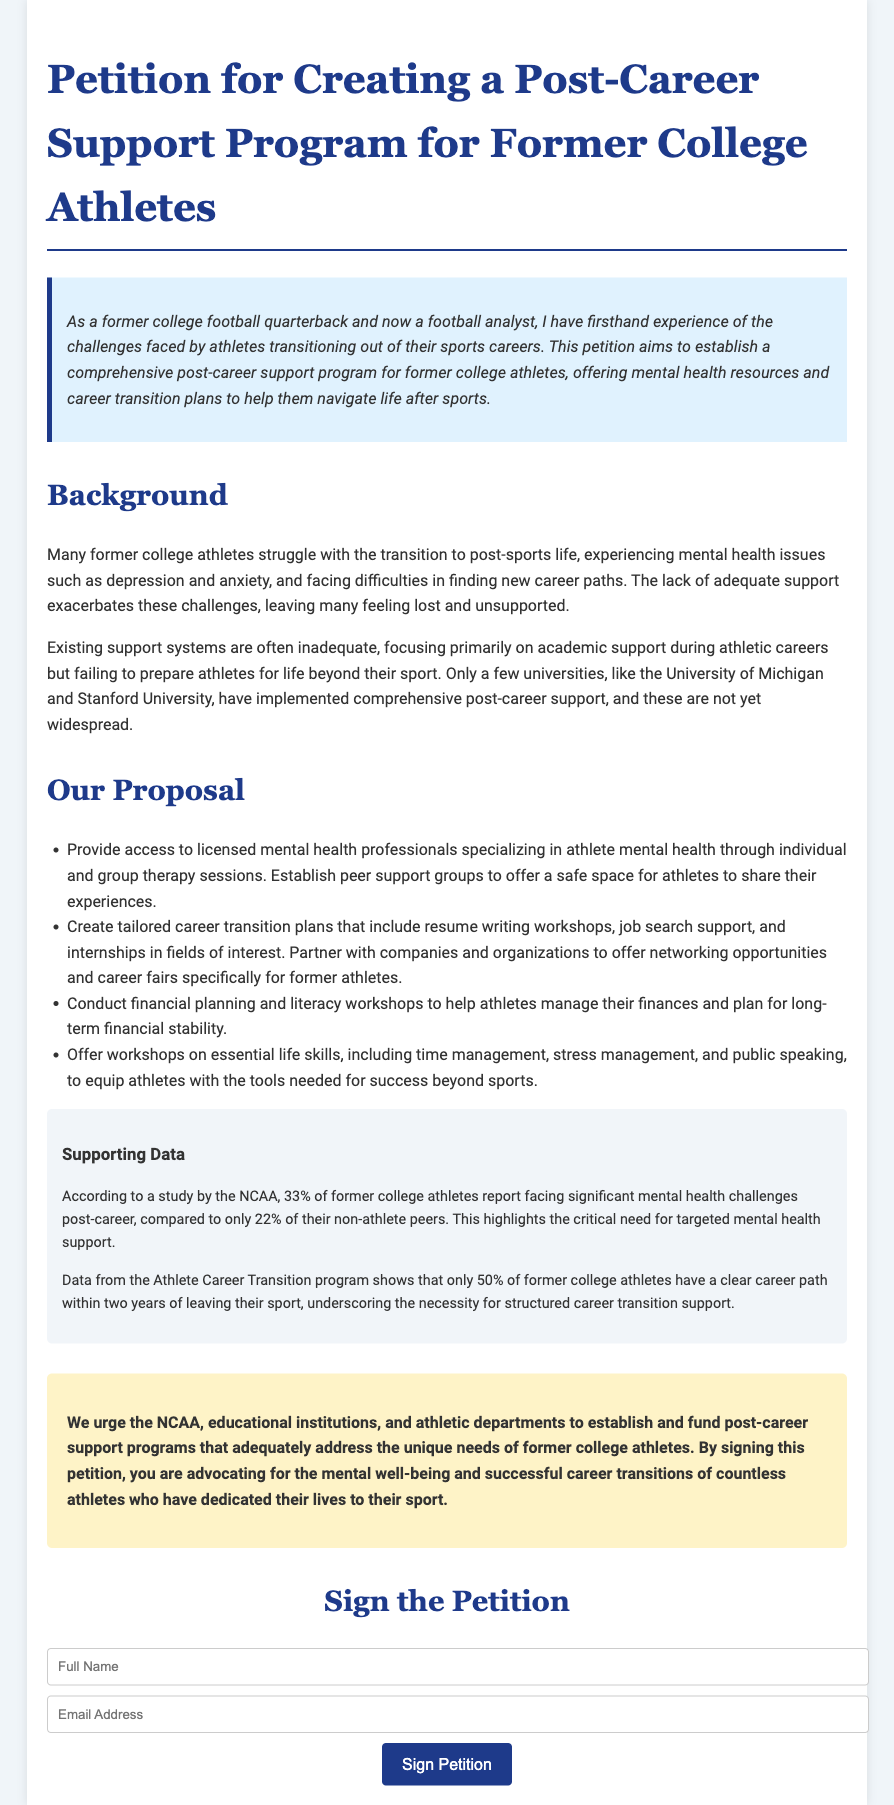what is the main goal of the petition? The main goal of the petition is to establish a comprehensive post-career support program for former college athletes, including mental health resources and career transition plans.
Answer: establish a comprehensive post-career support program who authored the petition? The petition is authored by a former college football quarterback who is now a football analyst.
Answer: a former college football quarterback what percentage of former college athletes face significant mental health challenges post-career? According to the document, 33% of former college athletes report facing significant mental health challenges post-career.
Answer: 33% what is one type of support proposed in the petition for mental health resources? The petition proposes to provide access to licensed mental health professionals specializing in athlete mental health.
Answer: access to licensed mental health professionals what percentage of former college athletes have a clear career path within two years of leaving their sport? Only 50% of former college athletes have a clear career path within two years of leaving their sport.
Answer: 50% which universities have implemented comprehensive post-career support programs? The petition mentions the University of Michigan and Stanford University as examples.
Answer: University of Michigan and Stanford University what type of workshops does the proposal include for financial planning? The proposal includes financial planning and literacy workshops.
Answer: financial planning and literacy workshops what are individuals urged to do by signing the petition? Individuals are urged to advocate for the mental well-being and successful career transitions of former athletes.
Answer: advocate for mental well-being and successful career transitions how is the petition visually presented? The document is presented in a structured HTML format with sections and styled elements.
Answer: structured HTML format with sections and styled elements 